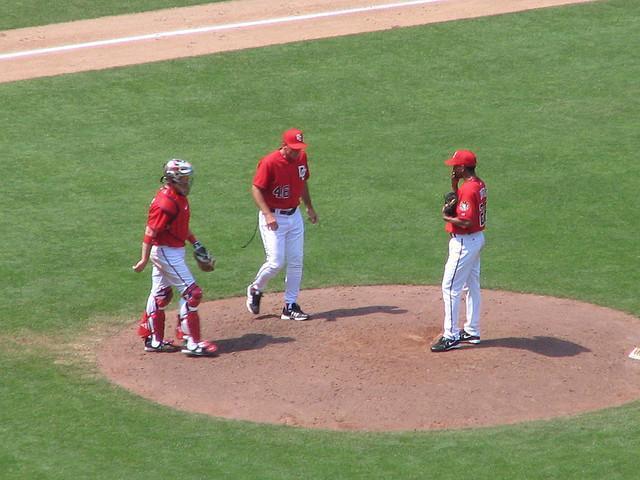How many people are there?
Give a very brief answer. 3. How many birds are in the picture?
Give a very brief answer. 0. 